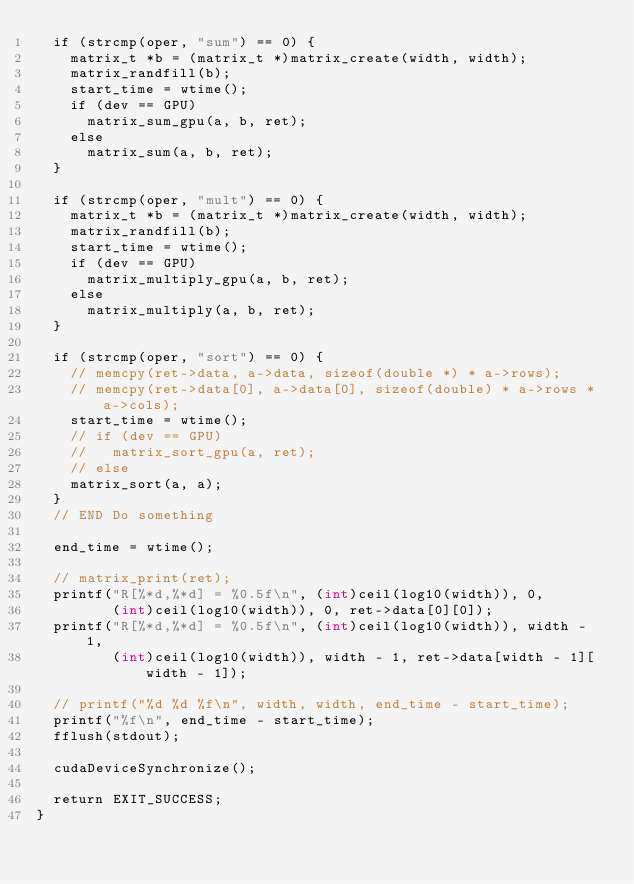<code> <loc_0><loc_0><loc_500><loc_500><_Cuda_>  if (strcmp(oper, "sum") == 0) {
    matrix_t *b = (matrix_t *)matrix_create(width, width);
    matrix_randfill(b);
    start_time = wtime();
    if (dev == GPU)
      matrix_sum_gpu(a, b, ret);
    else
      matrix_sum(a, b, ret);
  }

  if (strcmp(oper, "mult") == 0) {
    matrix_t *b = (matrix_t *)matrix_create(width, width);
    matrix_randfill(b);
    start_time = wtime();
    if (dev == GPU)
      matrix_multiply_gpu(a, b, ret);
    else
      matrix_multiply(a, b, ret);
  }

  if (strcmp(oper, "sort") == 0) {
    // memcpy(ret->data, a->data, sizeof(double *) * a->rows);
    // memcpy(ret->data[0], a->data[0], sizeof(double) * a->rows * a->cols);
    start_time = wtime();
    // if (dev == GPU)
    //   matrix_sort_gpu(a, ret);
    // else
    matrix_sort(a, a);
  }
  // END Do something

  end_time = wtime();

  // matrix_print(ret);
  printf("R[%*d,%*d] = %0.5f\n", (int)ceil(log10(width)), 0,
         (int)ceil(log10(width)), 0, ret->data[0][0]);
  printf("R[%*d,%*d] = %0.5f\n", (int)ceil(log10(width)), width - 1,
         (int)ceil(log10(width)), width - 1, ret->data[width - 1][width - 1]);

  // printf("%d %d %f\n", width, width, end_time - start_time);
  printf("%f\n", end_time - start_time);
  fflush(stdout);

  cudaDeviceSynchronize();

  return EXIT_SUCCESS;
}
</code> 